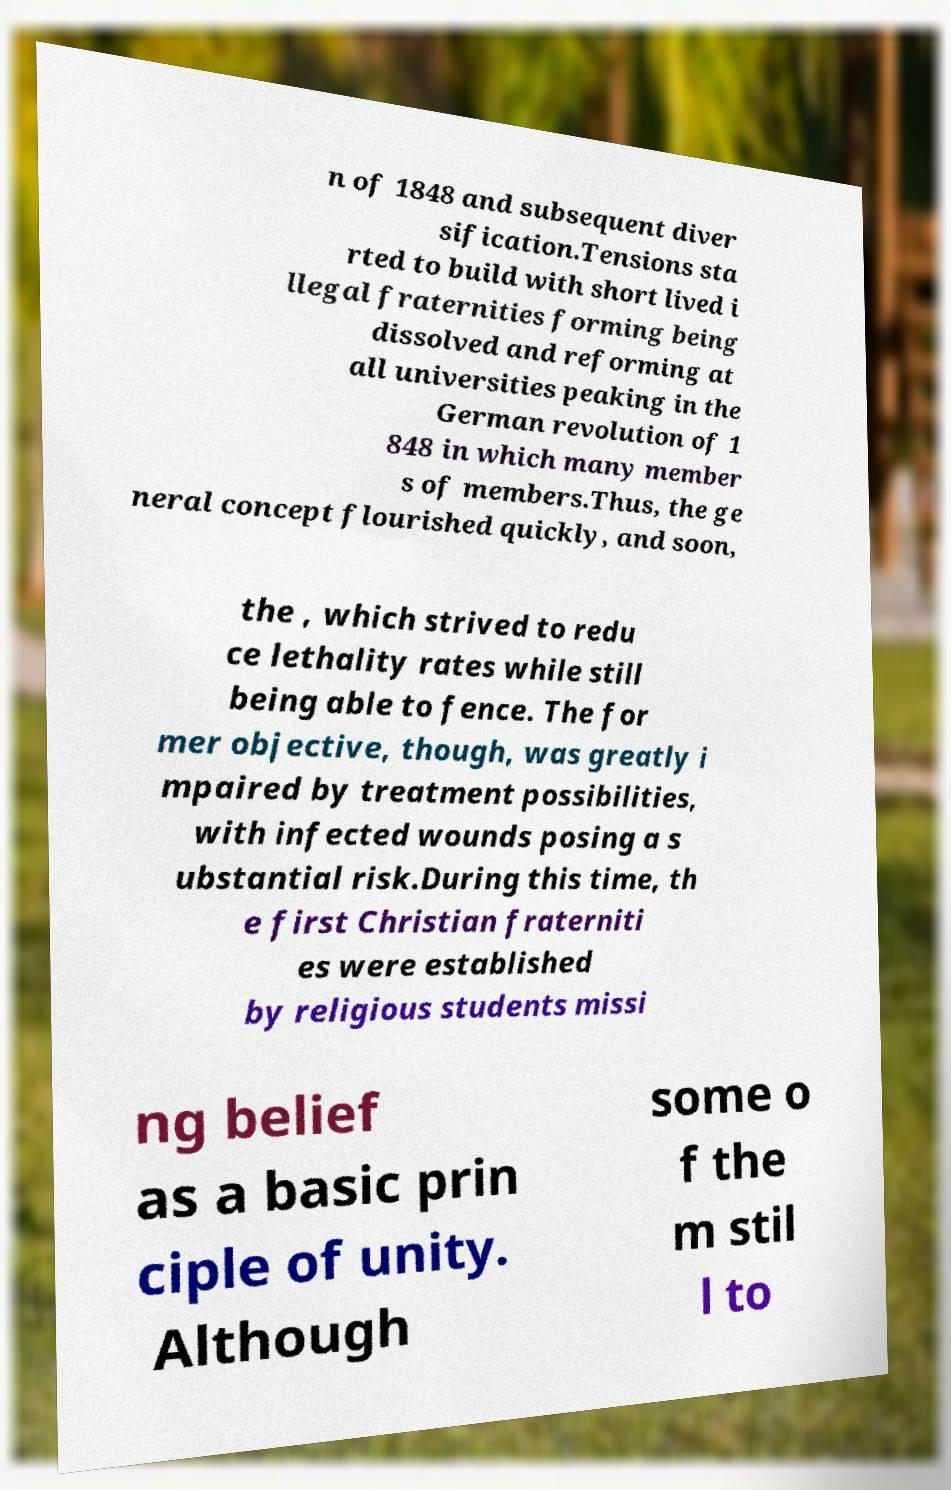Can you read and provide the text displayed in the image?This photo seems to have some interesting text. Can you extract and type it out for me? n of 1848 and subsequent diver sification.Tensions sta rted to build with short lived i llegal fraternities forming being dissolved and reforming at all universities peaking in the German revolution of 1 848 in which many member s of members.Thus, the ge neral concept flourished quickly, and soon, the , which strived to redu ce lethality rates while still being able to fence. The for mer objective, though, was greatly i mpaired by treatment possibilities, with infected wounds posing a s ubstantial risk.During this time, th e first Christian fraterniti es were established by religious students missi ng belief as a basic prin ciple of unity. Although some o f the m stil l to 